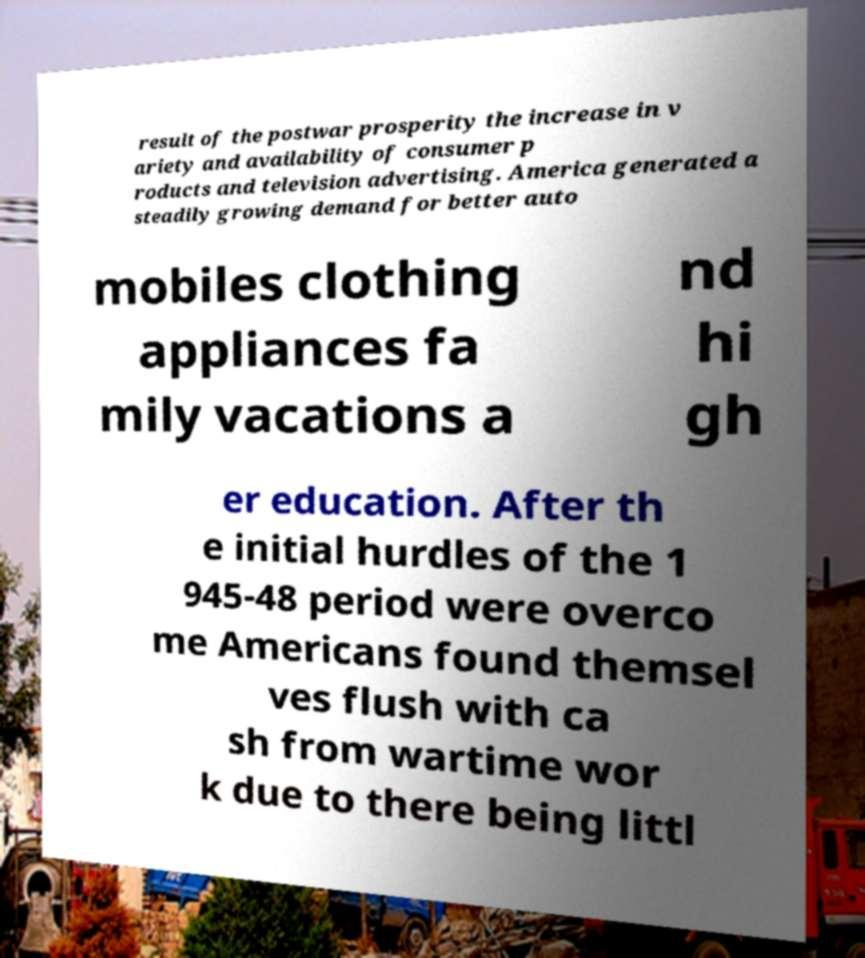Please identify and transcribe the text found in this image. result of the postwar prosperity the increase in v ariety and availability of consumer p roducts and television advertising. America generated a steadily growing demand for better auto mobiles clothing appliances fa mily vacations a nd hi gh er education. After th e initial hurdles of the 1 945-48 period were overco me Americans found themsel ves flush with ca sh from wartime wor k due to there being littl 